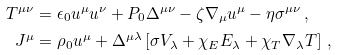<formula> <loc_0><loc_0><loc_500><loc_500>T ^ { \mu \nu } & = \epsilon _ { 0 } u ^ { \mu } u ^ { \nu } + P _ { 0 } \Delta ^ { \mu \nu } - \zeta \nabla _ { \mu } u ^ { \mu } - \eta \sigma ^ { \mu \nu } \, , \\ J ^ { \mu } & = \rho _ { 0 } u ^ { \mu } + \Delta ^ { \mu \lambda } \left [ \sigma V _ { \lambda } + \chi _ { E } E _ { \lambda } + \chi _ { T } \nabla _ { \lambda } T \right ] \, ,</formula> 